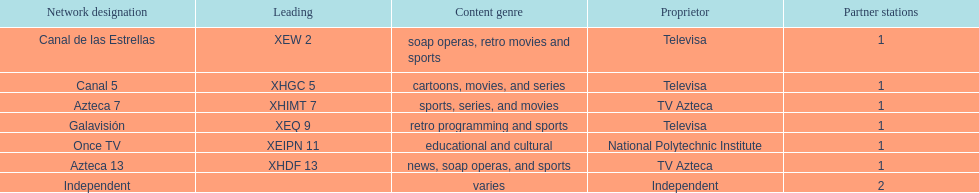What is the number of networks that are owned by televisa? 3. 